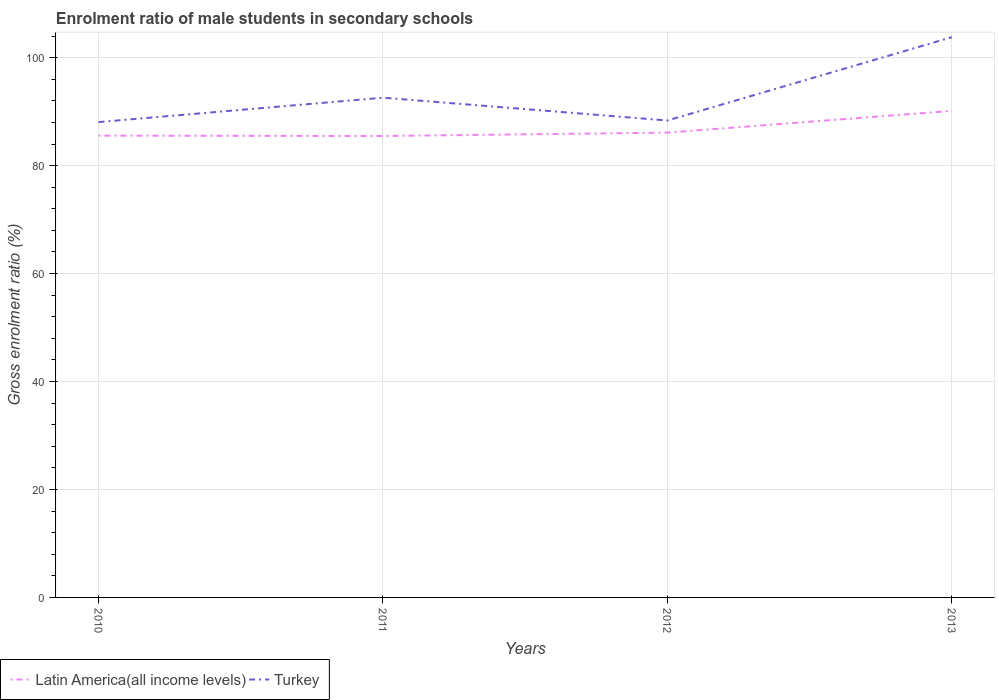How many different coloured lines are there?
Give a very brief answer. 2. Is the number of lines equal to the number of legend labels?
Make the answer very short. Yes. Across all years, what is the maximum enrolment ratio of male students in secondary schools in Latin America(all income levels)?
Your response must be concise. 85.49. In which year was the enrolment ratio of male students in secondary schools in Turkey maximum?
Keep it short and to the point. 2010. What is the total enrolment ratio of male students in secondary schools in Turkey in the graph?
Provide a succinct answer. -4.52. What is the difference between the highest and the second highest enrolment ratio of male students in secondary schools in Turkey?
Give a very brief answer. 15.73. Is the enrolment ratio of male students in secondary schools in Turkey strictly greater than the enrolment ratio of male students in secondary schools in Latin America(all income levels) over the years?
Keep it short and to the point. No. How many lines are there?
Your response must be concise. 2. How many years are there in the graph?
Provide a succinct answer. 4. Are the values on the major ticks of Y-axis written in scientific E-notation?
Your answer should be very brief. No. Does the graph contain any zero values?
Ensure brevity in your answer.  No. Does the graph contain grids?
Offer a very short reply. Yes. Where does the legend appear in the graph?
Your response must be concise. Bottom left. What is the title of the graph?
Give a very brief answer. Enrolment ratio of male students in secondary schools. Does "South Asia" appear as one of the legend labels in the graph?
Give a very brief answer. No. What is the label or title of the Y-axis?
Make the answer very short. Gross enrolment ratio (%). What is the Gross enrolment ratio (%) of Latin America(all income levels) in 2010?
Give a very brief answer. 85.55. What is the Gross enrolment ratio (%) of Turkey in 2010?
Your response must be concise. 88.06. What is the Gross enrolment ratio (%) of Latin America(all income levels) in 2011?
Your answer should be compact. 85.49. What is the Gross enrolment ratio (%) of Turkey in 2011?
Provide a short and direct response. 92.58. What is the Gross enrolment ratio (%) in Latin America(all income levels) in 2012?
Provide a succinct answer. 86.11. What is the Gross enrolment ratio (%) of Turkey in 2012?
Your answer should be very brief. 88.36. What is the Gross enrolment ratio (%) of Latin America(all income levels) in 2013?
Offer a terse response. 90.14. What is the Gross enrolment ratio (%) in Turkey in 2013?
Your answer should be compact. 103.79. Across all years, what is the maximum Gross enrolment ratio (%) in Latin America(all income levels)?
Keep it short and to the point. 90.14. Across all years, what is the maximum Gross enrolment ratio (%) in Turkey?
Ensure brevity in your answer.  103.79. Across all years, what is the minimum Gross enrolment ratio (%) of Latin America(all income levels)?
Ensure brevity in your answer.  85.49. Across all years, what is the minimum Gross enrolment ratio (%) of Turkey?
Make the answer very short. 88.06. What is the total Gross enrolment ratio (%) of Latin America(all income levels) in the graph?
Provide a short and direct response. 347.29. What is the total Gross enrolment ratio (%) of Turkey in the graph?
Keep it short and to the point. 372.8. What is the difference between the Gross enrolment ratio (%) in Latin America(all income levels) in 2010 and that in 2011?
Provide a succinct answer. 0.06. What is the difference between the Gross enrolment ratio (%) of Turkey in 2010 and that in 2011?
Give a very brief answer. -4.52. What is the difference between the Gross enrolment ratio (%) in Latin America(all income levels) in 2010 and that in 2012?
Keep it short and to the point. -0.56. What is the difference between the Gross enrolment ratio (%) of Turkey in 2010 and that in 2012?
Offer a terse response. -0.29. What is the difference between the Gross enrolment ratio (%) in Latin America(all income levels) in 2010 and that in 2013?
Provide a succinct answer. -4.59. What is the difference between the Gross enrolment ratio (%) in Turkey in 2010 and that in 2013?
Your answer should be compact. -15.73. What is the difference between the Gross enrolment ratio (%) in Latin America(all income levels) in 2011 and that in 2012?
Offer a very short reply. -0.62. What is the difference between the Gross enrolment ratio (%) in Turkey in 2011 and that in 2012?
Make the answer very short. 4.23. What is the difference between the Gross enrolment ratio (%) of Latin America(all income levels) in 2011 and that in 2013?
Make the answer very short. -4.66. What is the difference between the Gross enrolment ratio (%) in Turkey in 2011 and that in 2013?
Offer a terse response. -11.21. What is the difference between the Gross enrolment ratio (%) of Latin America(all income levels) in 2012 and that in 2013?
Provide a succinct answer. -4.03. What is the difference between the Gross enrolment ratio (%) of Turkey in 2012 and that in 2013?
Provide a succinct answer. -15.44. What is the difference between the Gross enrolment ratio (%) in Latin America(all income levels) in 2010 and the Gross enrolment ratio (%) in Turkey in 2011?
Ensure brevity in your answer.  -7.03. What is the difference between the Gross enrolment ratio (%) in Latin America(all income levels) in 2010 and the Gross enrolment ratio (%) in Turkey in 2012?
Your answer should be very brief. -2.81. What is the difference between the Gross enrolment ratio (%) of Latin America(all income levels) in 2010 and the Gross enrolment ratio (%) of Turkey in 2013?
Provide a short and direct response. -18.24. What is the difference between the Gross enrolment ratio (%) in Latin America(all income levels) in 2011 and the Gross enrolment ratio (%) in Turkey in 2012?
Make the answer very short. -2.87. What is the difference between the Gross enrolment ratio (%) of Latin America(all income levels) in 2011 and the Gross enrolment ratio (%) of Turkey in 2013?
Your answer should be compact. -18.31. What is the difference between the Gross enrolment ratio (%) in Latin America(all income levels) in 2012 and the Gross enrolment ratio (%) in Turkey in 2013?
Your answer should be compact. -17.68. What is the average Gross enrolment ratio (%) of Latin America(all income levels) per year?
Your answer should be very brief. 86.82. What is the average Gross enrolment ratio (%) of Turkey per year?
Your answer should be very brief. 93.2. In the year 2010, what is the difference between the Gross enrolment ratio (%) in Latin America(all income levels) and Gross enrolment ratio (%) in Turkey?
Ensure brevity in your answer.  -2.51. In the year 2011, what is the difference between the Gross enrolment ratio (%) of Latin America(all income levels) and Gross enrolment ratio (%) of Turkey?
Make the answer very short. -7.1. In the year 2012, what is the difference between the Gross enrolment ratio (%) of Latin America(all income levels) and Gross enrolment ratio (%) of Turkey?
Make the answer very short. -2.25. In the year 2013, what is the difference between the Gross enrolment ratio (%) of Latin America(all income levels) and Gross enrolment ratio (%) of Turkey?
Make the answer very short. -13.65. What is the ratio of the Gross enrolment ratio (%) in Turkey in 2010 to that in 2011?
Your answer should be compact. 0.95. What is the ratio of the Gross enrolment ratio (%) of Latin America(all income levels) in 2010 to that in 2013?
Ensure brevity in your answer.  0.95. What is the ratio of the Gross enrolment ratio (%) in Turkey in 2010 to that in 2013?
Offer a terse response. 0.85. What is the ratio of the Gross enrolment ratio (%) in Latin America(all income levels) in 2011 to that in 2012?
Your answer should be compact. 0.99. What is the ratio of the Gross enrolment ratio (%) of Turkey in 2011 to that in 2012?
Keep it short and to the point. 1.05. What is the ratio of the Gross enrolment ratio (%) in Latin America(all income levels) in 2011 to that in 2013?
Your answer should be compact. 0.95. What is the ratio of the Gross enrolment ratio (%) in Turkey in 2011 to that in 2013?
Ensure brevity in your answer.  0.89. What is the ratio of the Gross enrolment ratio (%) in Latin America(all income levels) in 2012 to that in 2013?
Provide a short and direct response. 0.96. What is the ratio of the Gross enrolment ratio (%) in Turkey in 2012 to that in 2013?
Give a very brief answer. 0.85. What is the difference between the highest and the second highest Gross enrolment ratio (%) in Latin America(all income levels)?
Offer a terse response. 4.03. What is the difference between the highest and the second highest Gross enrolment ratio (%) of Turkey?
Ensure brevity in your answer.  11.21. What is the difference between the highest and the lowest Gross enrolment ratio (%) of Latin America(all income levels)?
Your answer should be very brief. 4.66. What is the difference between the highest and the lowest Gross enrolment ratio (%) of Turkey?
Provide a short and direct response. 15.73. 